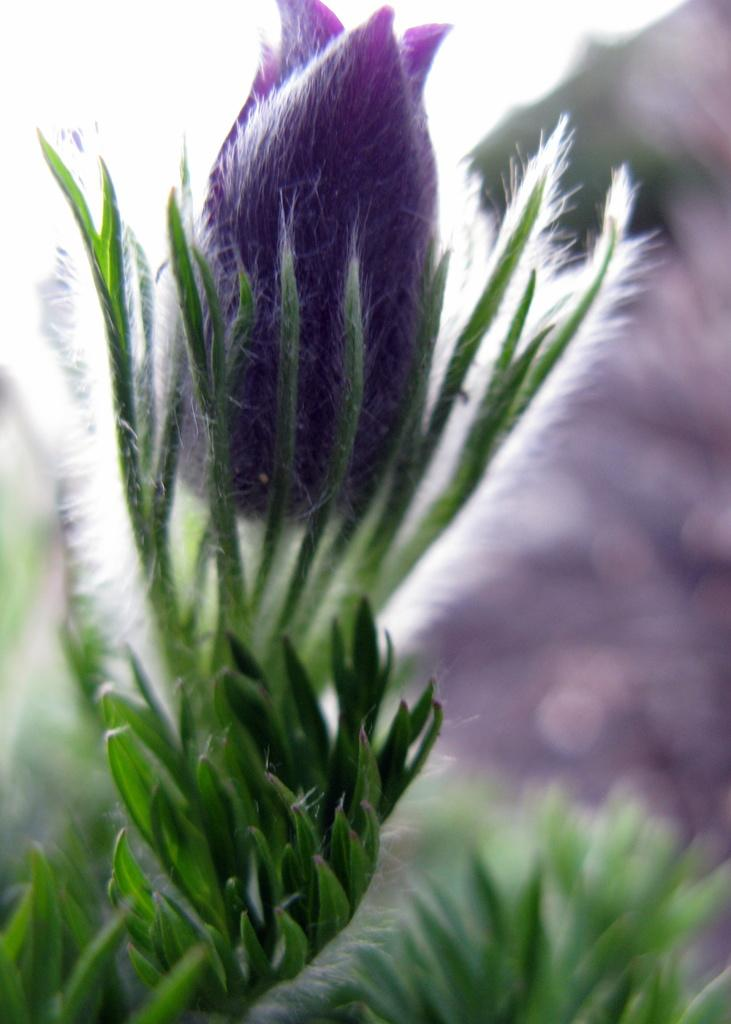What type of vegetation is present in the picture? There is grass and plants in the picture. What stage of growth are the plants in? The plants have buds. How many people are in the crowd depicted in the picture? There is no crowd present in the picture; it features grass and plants with buds. What type of calendar is visible in the picture? There is no calendar present in the picture; it features grass and plants with buds. 